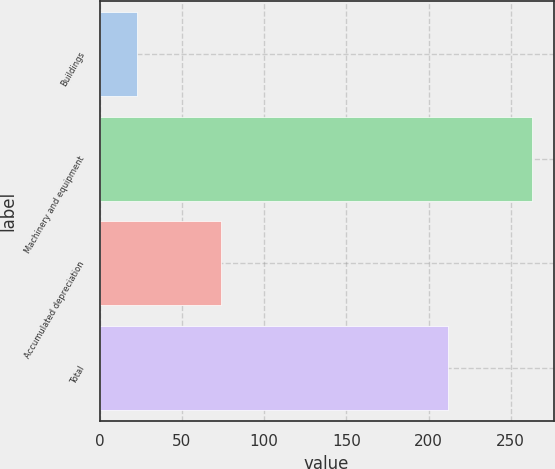Convert chart. <chart><loc_0><loc_0><loc_500><loc_500><bar_chart><fcel>Buildings<fcel>Machinery and equipment<fcel>Accumulated depreciation<fcel>Total<nl><fcel>23<fcel>263<fcel>74<fcel>212<nl></chart> 